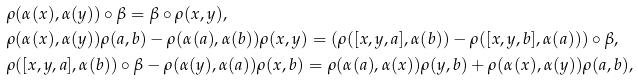Convert formula to latex. <formula><loc_0><loc_0><loc_500><loc_500>& \rho ( \alpha ( x ) , \alpha ( y ) ) \circ \beta = \beta \circ \rho ( x , y ) , \\ & \rho ( \alpha ( x ) , \alpha ( y ) ) \rho ( a , b ) - \rho ( \alpha ( a ) , \alpha ( b ) ) \rho ( x , y ) = ( \rho ( [ x , y , a ] , \alpha ( b ) ) - \rho ( [ x , y , b ] , \alpha ( a ) ) ) \circ \beta , \\ & \rho ( [ x , y , a ] , \alpha ( b ) ) \circ \beta - \rho ( \alpha ( y ) , \alpha ( a ) ) \rho ( x , b ) = \rho ( \alpha ( a ) , \alpha ( x ) ) \rho ( y , b ) + \rho ( \alpha ( x ) , \alpha ( y ) ) \rho ( a , b ) ,</formula> 